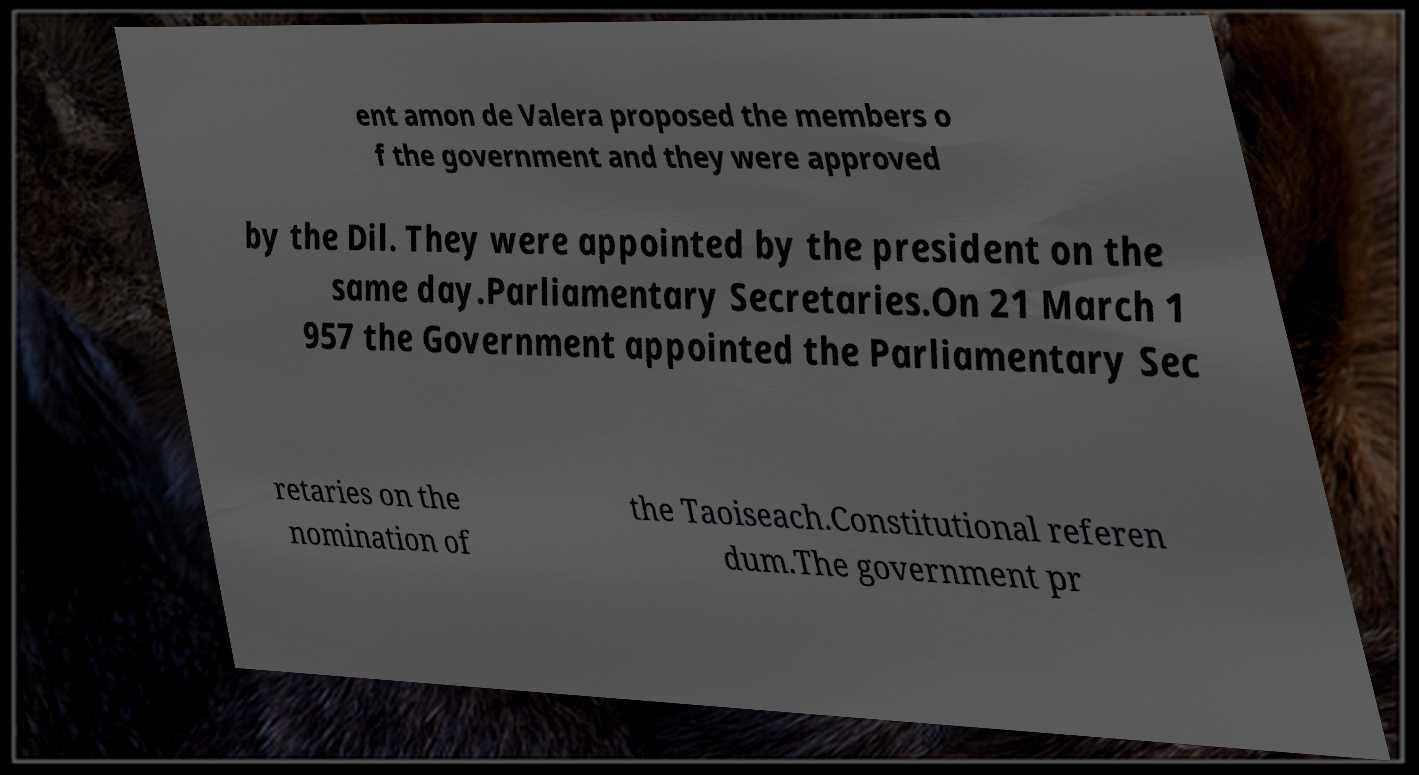Could you assist in decoding the text presented in this image and type it out clearly? ent amon de Valera proposed the members o f the government and they were approved by the Dil. They were appointed by the president on the same day.Parliamentary Secretaries.On 21 March 1 957 the Government appointed the Parliamentary Sec retaries on the nomination of the Taoiseach.Constitutional referen dum.The government pr 